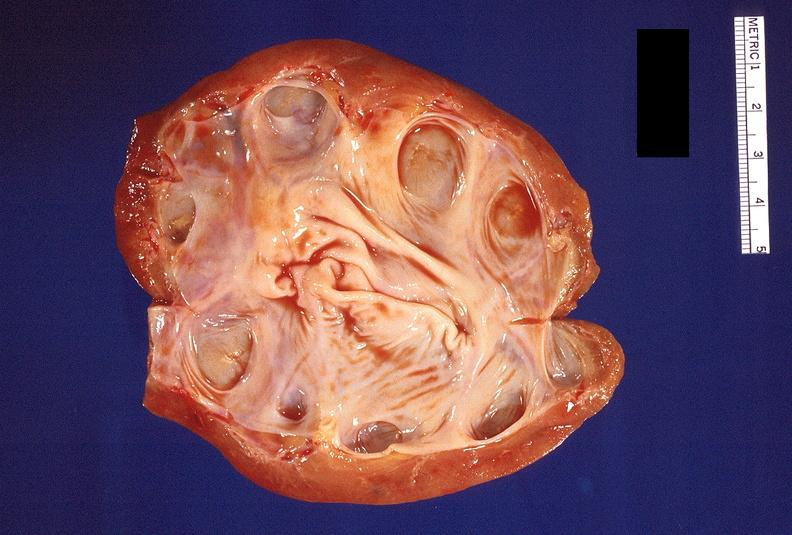where is this?
Answer the question using a single word or phrase. Urinary 